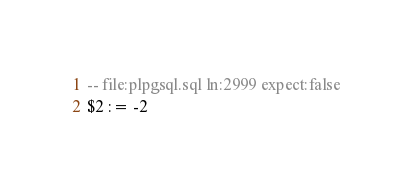<code> <loc_0><loc_0><loc_500><loc_500><_SQL_>-- file:plpgsql.sql ln:2999 expect:false
$2 := -2
</code> 